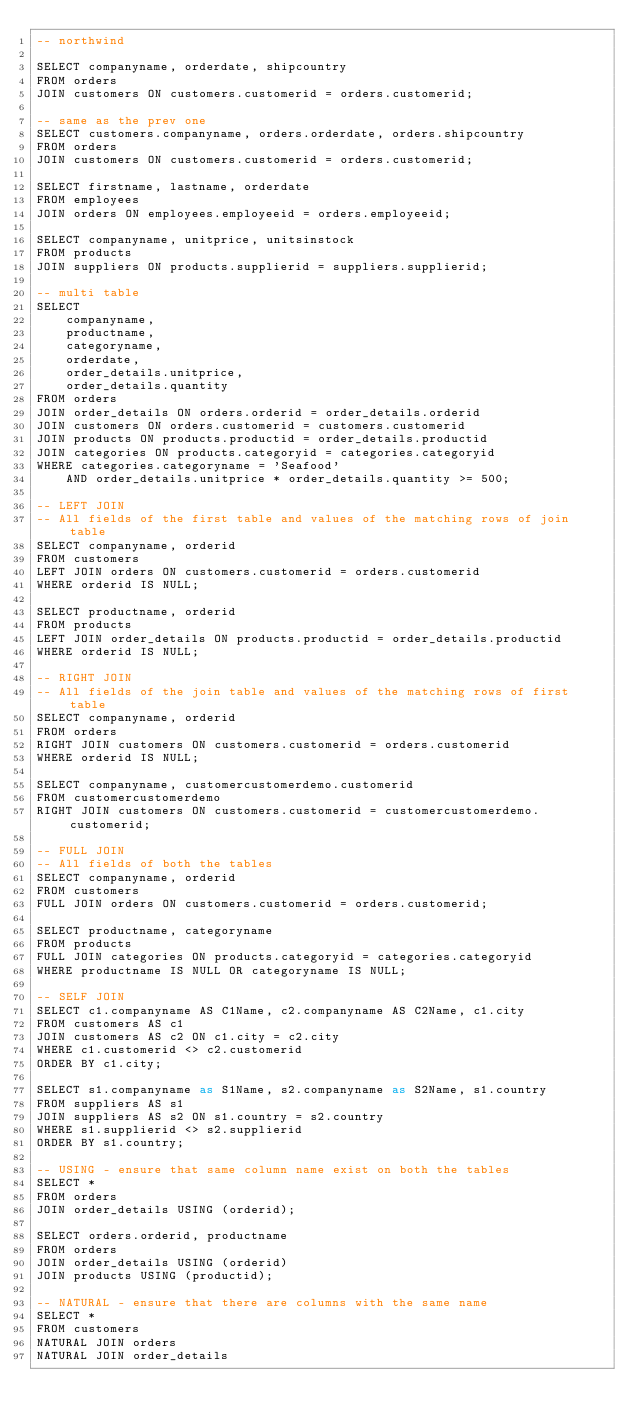<code> <loc_0><loc_0><loc_500><loc_500><_SQL_>-- northwind

SELECT companyname, orderdate, shipcountry
FROM orders
JOIN customers ON customers.customerid = orders.customerid;

-- same as the prev one
SELECT customers.companyname, orders.orderdate, orders.shipcountry
FROM orders
JOIN customers ON customers.customerid = orders.customerid;

SELECT firstname, lastname, orderdate
FROM employees
JOIN orders ON employees.employeeid = orders.employeeid;

SELECT companyname, unitprice, unitsinstock
FROM products
JOIN suppliers ON products.supplierid = suppliers.supplierid;

-- multi table
SELECT 
    companyname,
    productname,
    categoryname,
    orderdate,
    order_details.unitprice,
    order_details.quantity
FROM orders
JOIN order_details ON orders.orderid = order_details.orderid
JOIN customers ON orders.customerid = customers.customerid
JOIN products ON products.productid = order_details.productid
JOIN categories ON products.categoryid = categories.categoryid
WHERE categories.categoryname = 'Seafood'
    AND order_details.unitprice * order_details.quantity >= 500;

-- LEFT JOIN
-- All fields of the first table and values of the matching rows of join table
SELECT companyname, orderid
FROM customers
LEFT JOIN orders ON customers.customerid = orders.customerid
WHERE orderid IS NULL;

SELECT productname, orderid
FROM products
LEFT JOIN order_details ON products.productid = order_details.productid
WHERE orderid IS NULL;

-- RIGHT JOIN
-- All fields of the join table and values of the matching rows of first table
SELECT companyname, orderid
FROM orders
RIGHT JOIN customers ON customers.customerid = orders.customerid
WHERE orderid IS NULL;

SELECT companyname, customercustomerdemo.customerid
FROM customercustomerdemo
RIGHT JOIN customers ON customers.customerid = customercustomerdemo.customerid;

-- FULL JOIN
-- All fields of both the tables
SELECT companyname, orderid
FROM customers
FULL JOIN orders ON customers.customerid = orders.customerid;

SELECT productname, categoryname
FROM products
FULL JOIN categories ON products.categoryid = categories.categoryid
WHERE productname IS NULL OR categoryname IS NULL;

-- SELF JOIN
SELECT c1.companyname AS C1Name, c2.companyname AS C2Name, c1.city
FROM customers AS c1
JOIN customers AS c2 ON c1.city = c2.city
WHERE c1.customerid <> c2.customerid
ORDER BY c1.city;

SELECT s1.companyname as S1Name, s2.companyname as S2Name, s1.country
FROM suppliers AS s1
JOIN suppliers AS s2 ON s1.country = s2.country
WHERE s1.supplierid <> s2.supplierid
ORDER BY s1.country;

-- USING - ensure that same column name exist on both the tables
SELECT *
FROM orders
JOIN order_details USING (orderid);

SELECT orders.orderid, productname
FROM orders
JOIN order_details USING (orderid)
JOIN products USING (productid);

-- NATURAL - ensure that there are columns with the same name
SELECT *
FROM customers
NATURAL JOIN orders
NATURAL JOIN order_details</code> 